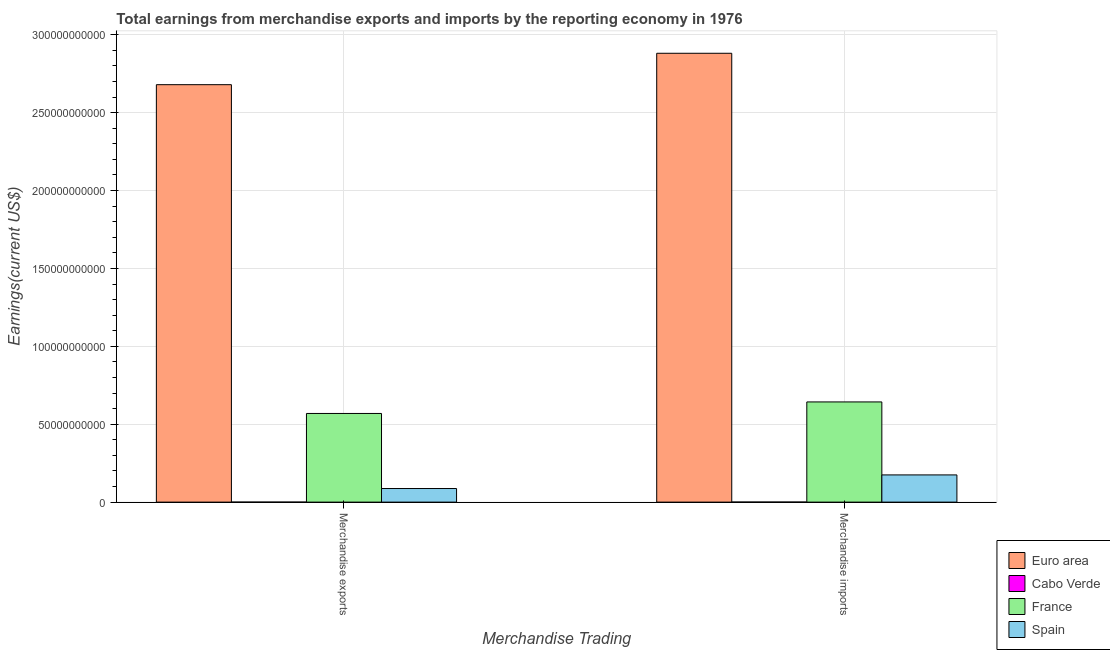How many groups of bars are there?
Give a very brief answer. 2. Are the number of bars on each tick of the X-axis equal?
Provide a short and direct response. Yes. What is the label of the 1st group of bars from the left?
Offer a terse response. Merchandise exports. What is the earnings from merchandise exports in Euro area?
Keep it short and to the point. 2.68e+11. Across all countries, what is the maximum earnings from merchandise exports?
Keep it short and to the point. 2.68e+11. Across all countries, what is the minimum earnings from merchandise exports?
Your answer should be compact. 1.50e+06. In which country was the earnings from merchandise imports minimum?
Offer a terse response. Cabo Verde. What is the total earnings from merchandise exports in the graph?
Provide a short and direct response. 3.34e+11. What is the difference between the earnings from merchandise imports in Spain and that in Cabo Verde?
Offer a terse response. 1.74e+1. What is the difference between the earnings from merchandise imports in France and the earnings from merchandise exports in Cabo Verde?
Make the answer very short. 6.43e+1. What is the average earnings from merchandise imports per country?
Your response must be concise. 9.25e+1. What is the difference between the earnings from merchandise exports and earnings from merchandise imports in Spain?
Provide a short and direct response. -8.74e+09. What is the ratio of the earnings from merchandise imports in Cabo Verde to that in France?
Offer a very short reply. 0. Is the earnings from merchandise imports in France less than that in Spain?
Ensure brevity in your answer.  No. What does the 1st bar from the left in Merchandise imports represents?
Provide a succinct answer. Euro area. How many countries are there in the graph?
Your answer should be very brief. 4. Does the graph contain any zero values?
Offer a terse response. No. Where does the legend appear in the graph?
Ensure brevity in your answer.  Bottom right. How many legend labels are there?
Keep it short and to the point. 4. How are the legend labels stacked?
Your response must be concise. Vertical. What is the title of the graph?
Provide a short and direct response. Total earnings from merchandise exports and imports by the reporting economy in 1976. Does "Middle East & North Africa (all income levels)" appear as one of the legend labels in the graph?
Your answer should be compact. No. What is the label or title of the X-axis?
Provide a succinct answer. Merchandise Trading. What is the label or title of the Y-axis?
Ensure brevity in your answer.  Earnings(current US$). What is the Earnings(current US$) of Euro area in Merchandise exports?
Make the answer very short. 2.68e+11. What is the Earnings(current US$) in Cabo Verde in Merchandise exports?
Offer a terse response. 1.50e+06. What is the Earnings(current US$) in France in Merchandise exports?
Your answer should be very brief. 5.69e+1. What is the Earnings(current US$) of Spain in Merchandise exports?
Your answer should be very brief. 8.73e+09. What is the Earnings(current US$) in Euro area in Merchandise imports?
Your answer should be compact. 2.88e+11. What is the Earnings(current US$) of Cabo Verde in Merchandise imports?
Make the answer very short. 3.00e+07. What is the Earnings(current US$) of France in Merchandise imports?
Keep it short and to the point. 6.43e+1. What is the Earnings(current US$) of Spain in Merchandise imports?
Provide a short and direct response. 1.75e+1. Across all Merchandise Trading, what is the maximum Earnings(current US$) of Euro area?
Offer a very short reply. 2.88e+11. Across all Merchandise Trading, what is the maximum Earnings(current US$) in Cabo Verde?
Offer a terse response. 3.00e+07. Across all Merchandise Trading, what is the maximum Earnings(current US$) in France?
Ensure brevity in your answer.  6.43e+1. Across all Merchandise Trading, what is the maximum Earnings(current US$) of Spain?
Ensure brevity in your answer.  1.75e+1. Across all Merchandise Trading, what is the minimum Earnings(current US$) in Euro area?
Your answer should be very brief. 2.68e+11. Across all Merchandise Trading, what is the minimum Earnings(current US$) in Cabo Verde?
Your response must be concise. 1.50e+06. Across all Merchandise Trading, what is the minimum Earnings(current US$) of France?
Give a very brief answer. 5.69e+1. Across all Merchandise Trading, what is the minimum Earnings(current US$) in Spain?
Your answer should be very brief. 8.73e+09. What is the total Earnings(current US$) in Euro area in the graph?
Offer a very short reply. 5.56e+11. What is the total Earnings(current US$) in Cabo Verde in the graph?
Ensure brevity in your answer.  3.15e+07. What is the total Earnings(current US$) of France in the graph?
Make the answer very short. 1.21e+11. What is the total Earnings(current US$) of Spain in the graph?
Your answer should be compact. 2.62e+1. What is the difference between the Earnings(current US$) of Euro area in Merchandise exports and that in Merchandise imports?
Ensure brevity in your answer.  -2.02e+1. What is the difference between the Earnings(current US$) of Cabo Verde in Merchandise exports and that in Merchandise imports?
Provide a succinct answer. -2.85e+07. What is the difference between the Earnings(current US$) in France in Merchandise exports and that in Merchandise imports?
Your response must be concise. -7.40e+09. What is the difference between the Earnings(current US$) of Spain in Merchandise exports and that in Merchandise imports?
Your answer should be compact. -8.74e+09. What is the difference between the Earnings(current US$) of Euro area in Merchandise exports and the Earnings(current US$) of Cabo Verde in Merchandise imports?
Your response must be concise. 2.68e+11. What is the difference between the Earnings(current US$) of Euro area in Merchandise exports and the Earnings(current US$) of France in Merchandise imports?
Keep it short and to the point. 2.04e+11. What is the difference between the Earnings(current US$) of Euro area in Merchandise exports and the Earnings(current US$) of Spain in Merchandise imports?
Your answer should be very brief. 2.50e+11. What is the difference between the Earnings(current US$) in Cabo Verde in Merchandise exports and the Earnings(current US$) in France in Merchandise imports?
Give a very brief answer. -6.43e+1. What is the difference between the Earnings(current US$) of Cabo Verde in Merchandise exports and the Earnings(current US$) of Spain in Merchandise imports?
Provide a succinct answer. -1.75e+1. What is the difference between the Earnings(current US$) of France in Merchandise exports and the Earnings(current US$) of Spain in Merchandise imports?
Give a very brief answer. 3.95e+1. What is the average Earnings(current US$) in Euro area per Merchandise Trading?
Give a very brief answer. 2.78e+11. What is the average Earnings(current US$) of Cabo Verde per Merchandise Trading?
Provide a short and direct response. 1.58e+07. What is the average Earnings(current US$) of France per Merchandise Trading?
Make the answer very short. 6.06e+1. What is the average Earnings(current US$) in Spain per Merchandise Trading?
Your response must be concise. 1.31e+1. What is the difference between the Earnings(current US$) in Euro area and Earnings(current US$) in Cabo Verde in Merchandise exports?
Your answer should be compact. 2.68e+11. What is the difference between the Earnings(current US$) in Euro area and Earnings(current US$) in France in Merchandise exports?
Provide a short and direct response. 2.11e+11. What is the difference between the Earnings(current US$) of Euro area and Earnings(current US$) of Spain in Merchandise exports?
Make the answer very short. 2.59e+11. What is the difference between the Earnings(current US$) of Cabo Verde and Earnings(current US$) of France in Merchandise exports?
Offer a terse response. -5.69e+1. What is the difference between the Earnings(current US$) in Cabo Verde and Earnings(current US$) in Spain in Merchandise exports?
Keep it short and to the point. -8.72e+09. What is the difference between the Earnings(current US$) of France and Earnings(current US$) of Spain in Merchandise exports?
Keep it short and to the point. 4.82e+1. What is the difference between the Earnings(current US$) in Euro area and Earnings(current US$) in Cabo Verde in Merchandise imports?
Offer a very short reply. 2.88e+11. What is the difference between the Earnings(current US$) of Euro area and Earnings(current US$) of France in Merchandise imports?
Offer a very short reply. 2.24e+11. What is the difference between the Earnings(current US$) in Euro area and Earnings(current US$) in Spain in Merchandise imports?
Your response must be concise. 2.71e+11. What is the difference between the Earnings(current US$) in Cabo Verde and Earnings(current US$) in France in Merchandise imports?
Keep it short and to the point. -6.43e+1. What is the difference between the Earnings(current US$) in Cabo Verde and Earnings(current US$) in Spain in Merchandise imports?
Keep it short and to the point. -1.74e+1. What is the difference between the Earnings(current US$) of France and Earnings(current US$) of Spain in Merchandise imports?
Offer a very short reply. 4.68e+1. What is the ratio of the Earnings(current US$) in Euro area in Merchandise exports to that in Merchandise imports?
Give a very brief answer. 0.93. What is the ratio of the Earnings(current US$) of France in Merchandise exports to that in Merchandise imports?
Make the answer very short. 0.89. What is the ratio of the Earnings(current US$) of Spain in Merchandise exports to that in Merchandise imports?
Offer a very short reply. 0.5. What is the difference between the highest and the second highest Earnings(current US$) in Euro area?
Make the answer very short. 2.02e+1. What is the difference between the highest and the second highest Earnings(current US$) of Cabo Verde?
Keep it short and to the point. 2.85e+07. What is the difference between the highest and the second highest Earnings(current US$) of France?
Your answer should be very brief. 7.40e+09. What is the difference between the highest and the second highest Earnings(current US$) of Spain?
Your answer should be very brief. 8.74e+09. What is the difference between the highest and the lowest Earnings(current US$) of Euro area?
Provide a succinct answer. 2.02e+1. What is the difference between the highest and the lowest Earnings(current US$) in Cabo Verde?
Give a very brief answer. 2.85e+07. What is the difference between the highest and the lowest Earnings(current US$) in France?
Your answer should be compact. 7.40e+09. What is the difference between the highest and the lowest Earnings(current US$) in Spain?
Keep it short and to the point. 8.74e+09. 